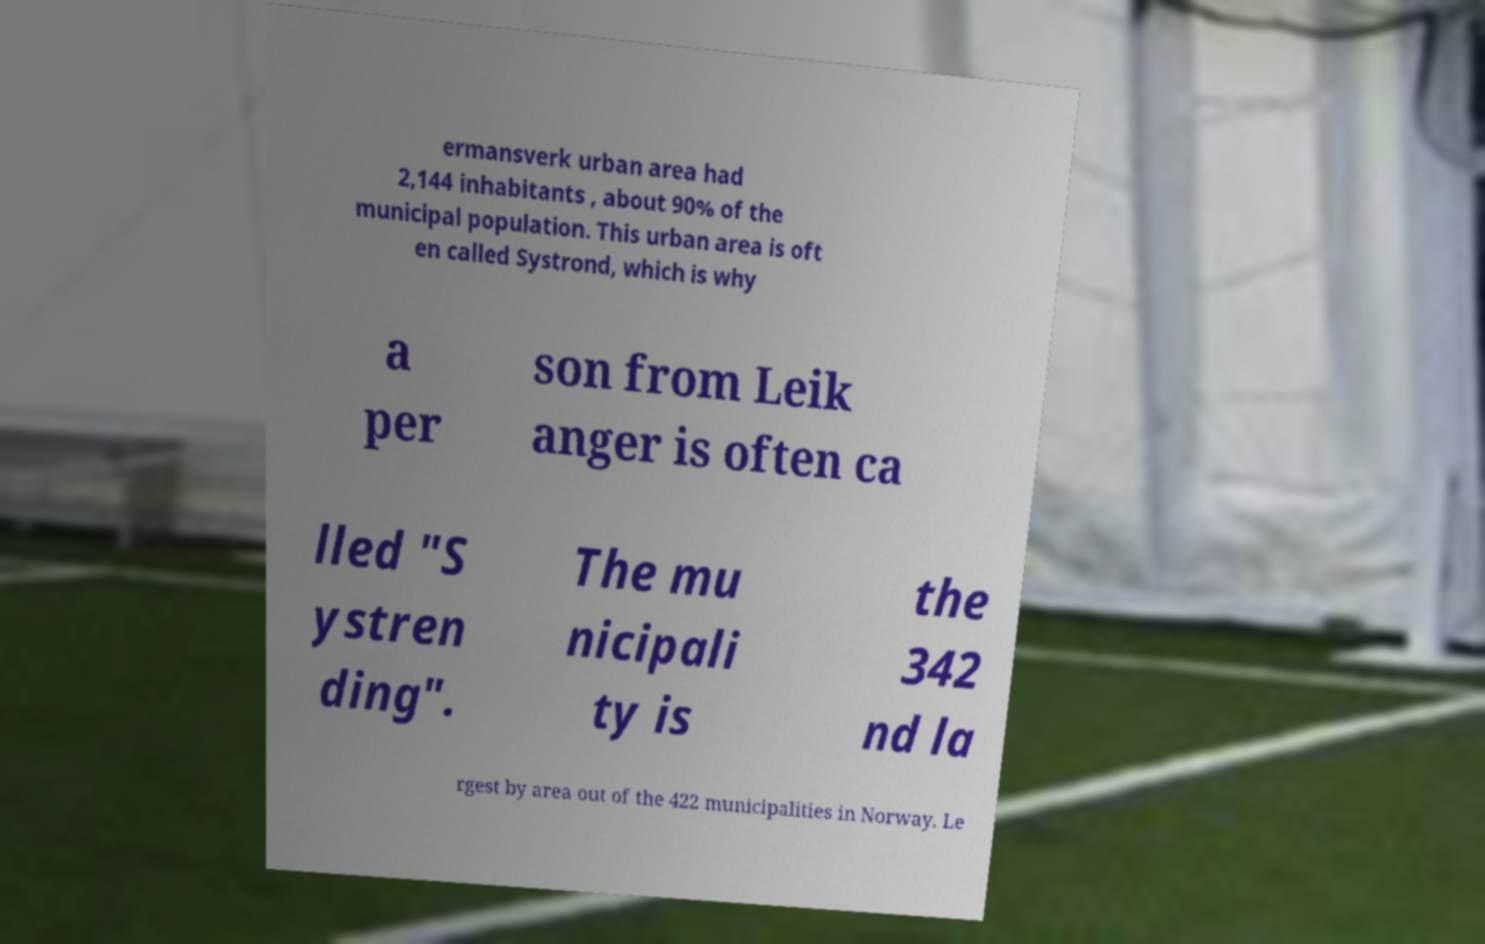What messages or text are displayed in this image? I need them in a readable, typed format. ermansverk urban area had 2,144 inhabitants , about 90% of the municipal population. This urban area is oft en called Systrond, which is why a per son from Leik anger is often ca lled "S ystren ding". The mu nicipali ty is the 342 nd la rgest by area out of the 422 municipalities in Norway. Le 